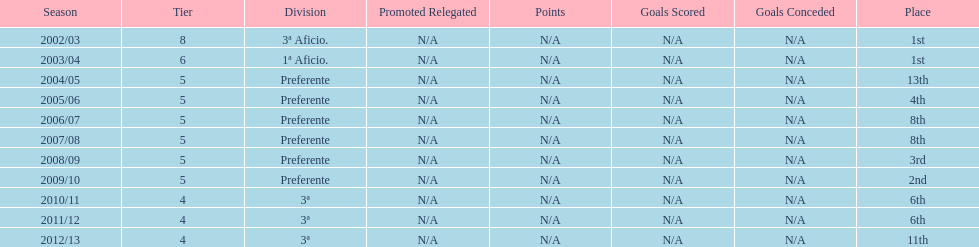How long did the team stay in first place? 2 years. 